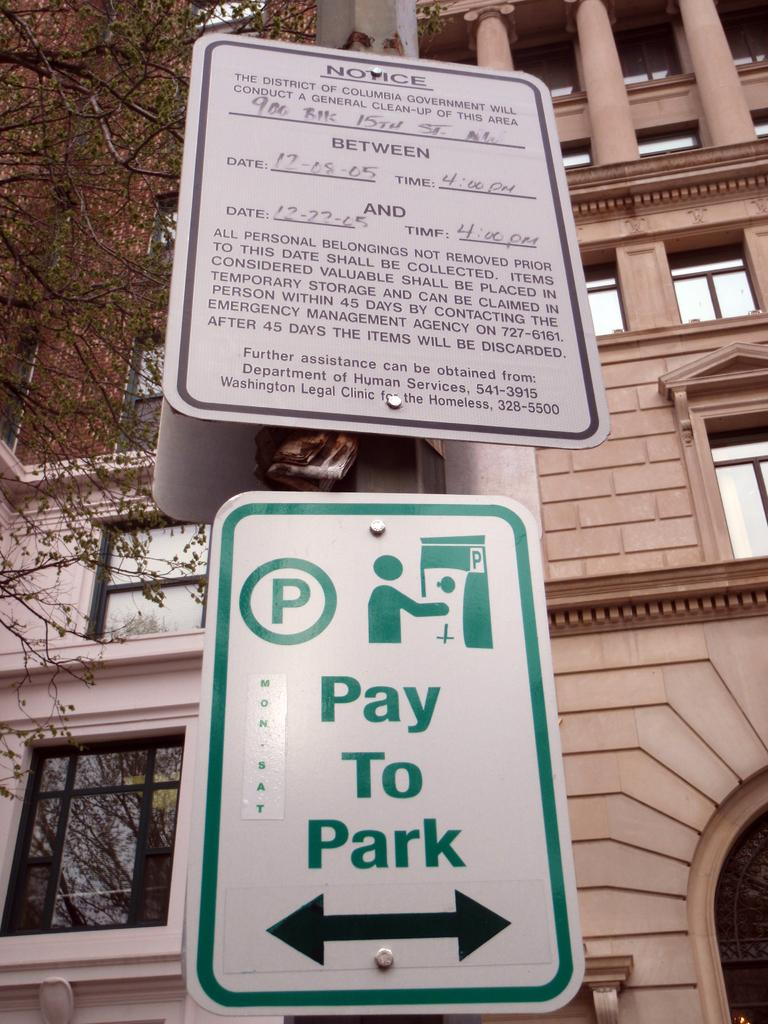<image>
Provide a brief description of the given image. Notice sign on the side walk that you must pay to park 